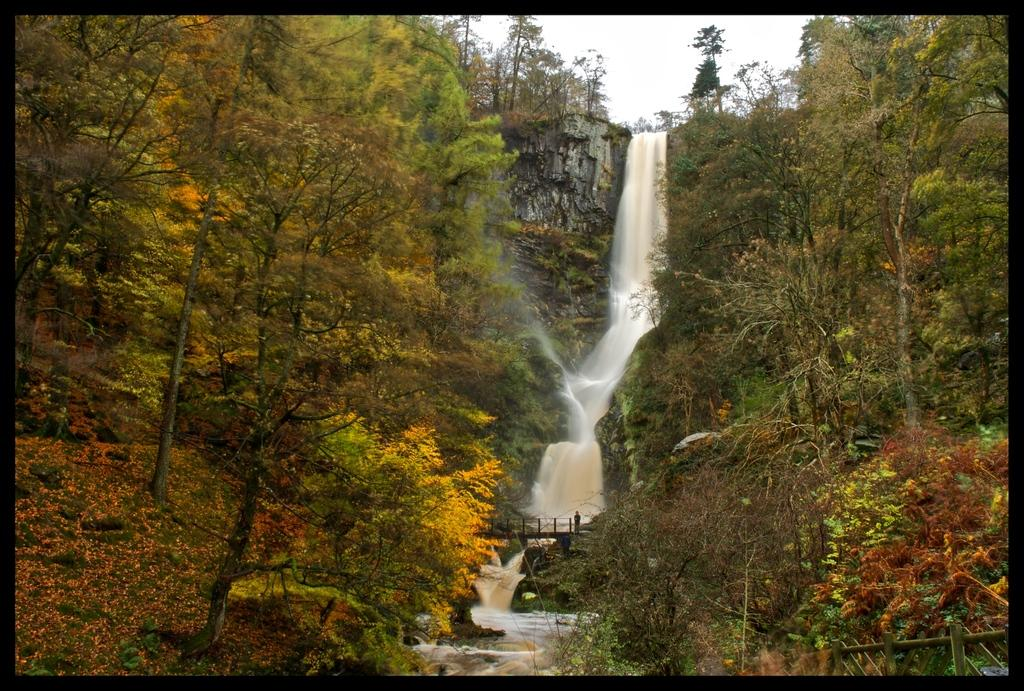What natural feature is the main subject of the image? There is a waterfall in the image. What type of vegetation can be seen in the image? There are trees and grass in the image. What man-made structure is present in the image? There is a wooden fence in the image. What is visible in the background of the image? The sky is visible in the image. Can you describe the person in the image? There is a person standing on a bridge in the image. What type of machine can be seen operating in the waterfall in the image? There is no machine present in the image; it features a waterfall, trees, grass, a wooden fence, the sky, and a person standing on a bridge. How many fingers does the person have in the image? The image does not provide enough detail to determine the number of fingers the person has. 